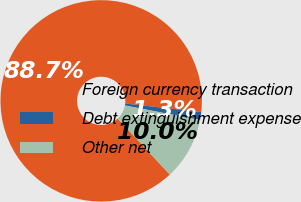<chart> <loc_0><loc_0><loc_500><loc_500><pie_chart><fcel>Foreign currency transaction<fcel>Debt extinguishment expense<fcel>Other net<nl><fcel>88.69%<fcel>1.28%<fcel>10.02%<nl></chart> 